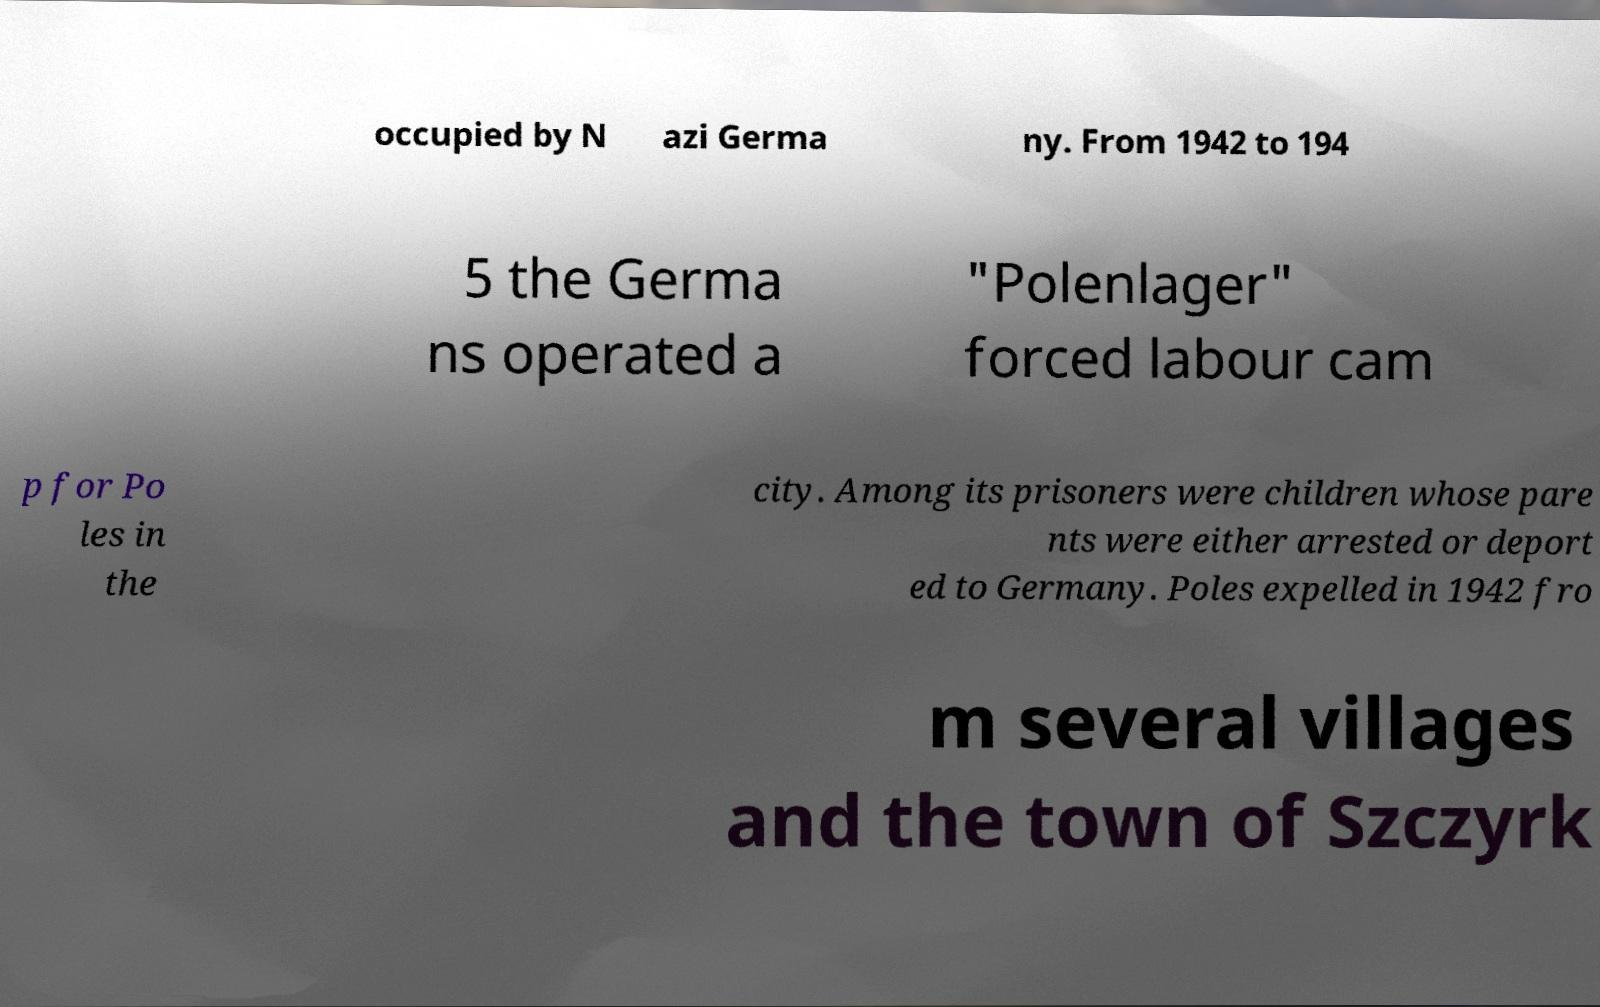There's text embedded in this image that I need extracted. Can you transcribe it verbatim? occupied by N azi Germa ny. From 1942 to 194 5 the Germa ns operated a "Polenlager" forced labour cam p for Po les in the city. Among its prisoners were children whose pare nts were either arrested or deport ed to Germany. Poles expelled in 1942 fro m several villages and the town of Szczyrk 